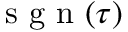Convert formula to latex. <formula><loc_0><loc_0><loc_500><loc_500>s g n ( \tau )</formula> 